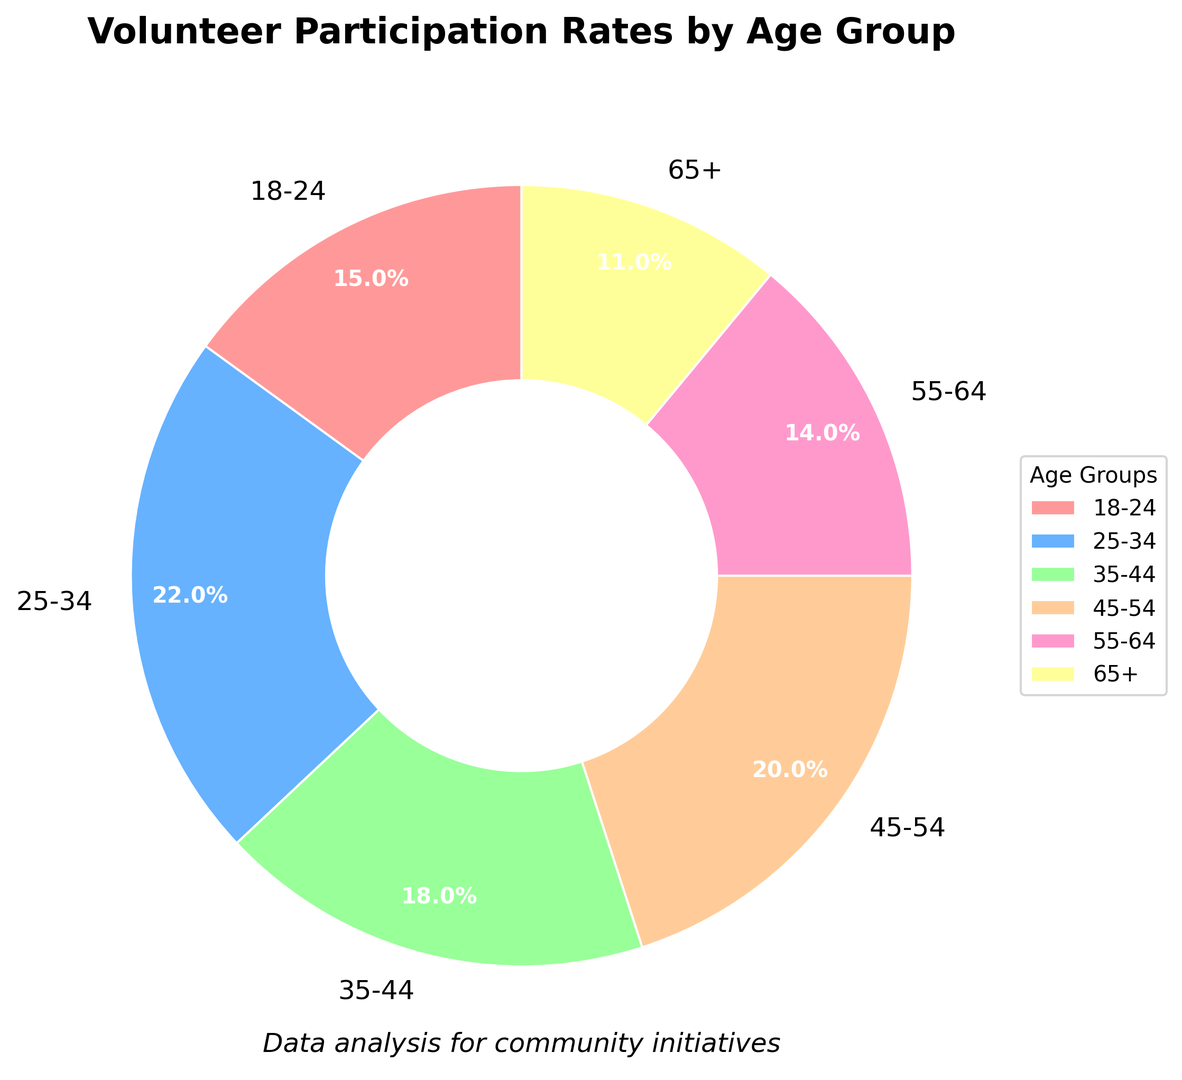What is the age group with the highest volunteer participation rate? Look at the chart and find the age group with the largest section. This is the 25-34 age group with a 22% participation rate.
Answer: 25-34 Which age group has the lowest participation rate? Find the smallest section in the pie chart, which corresponds to the 65+ age group with an 11% participation rate.
Answer: 65+ What is the combined participation rate of the 35-44 and 45-54 age groups? Add the participation rates of these two age groups: 18% (35-44) + 20% (45-54) = 38%.
Answer: 38% How much is the participation rate of the 18-24 age group less than the 25-34 age group? Subtract the 18-24 rate from the 25-34 rate: 22% - 15% = 7%.
Answer: 7% Which age group is represented by the wedge with the reddish color? Identify the reddish color in the pie chart, which corresponds to the 18-24 age group.
Answer: 18-24 How does the participation rate of the 55-64 age group compare to the 45-54 age group? Compare the rates: 14% (55-64) is less than 20% (45-54).
Answer: Less What is the average participation rate across all age groups? Sum the rates and divide by the number of groups: (15% + 22% + 18% + 20% + 14% + 11%) / 6 = 16.67%.
Answer: 16.67% Which age group has a participation rate closest to the average rate? The average rate is 16.67%, and the closest rate is 18% (35-44 age group).
Answer: 35-44 How does the 55-64 age group's participation rate visually differ from that of the 18-24 age group? The 55-64 age group's section is slightly smaller than the 18-24 age group's section in the pie chart.
Answer: Slightly Smaller 